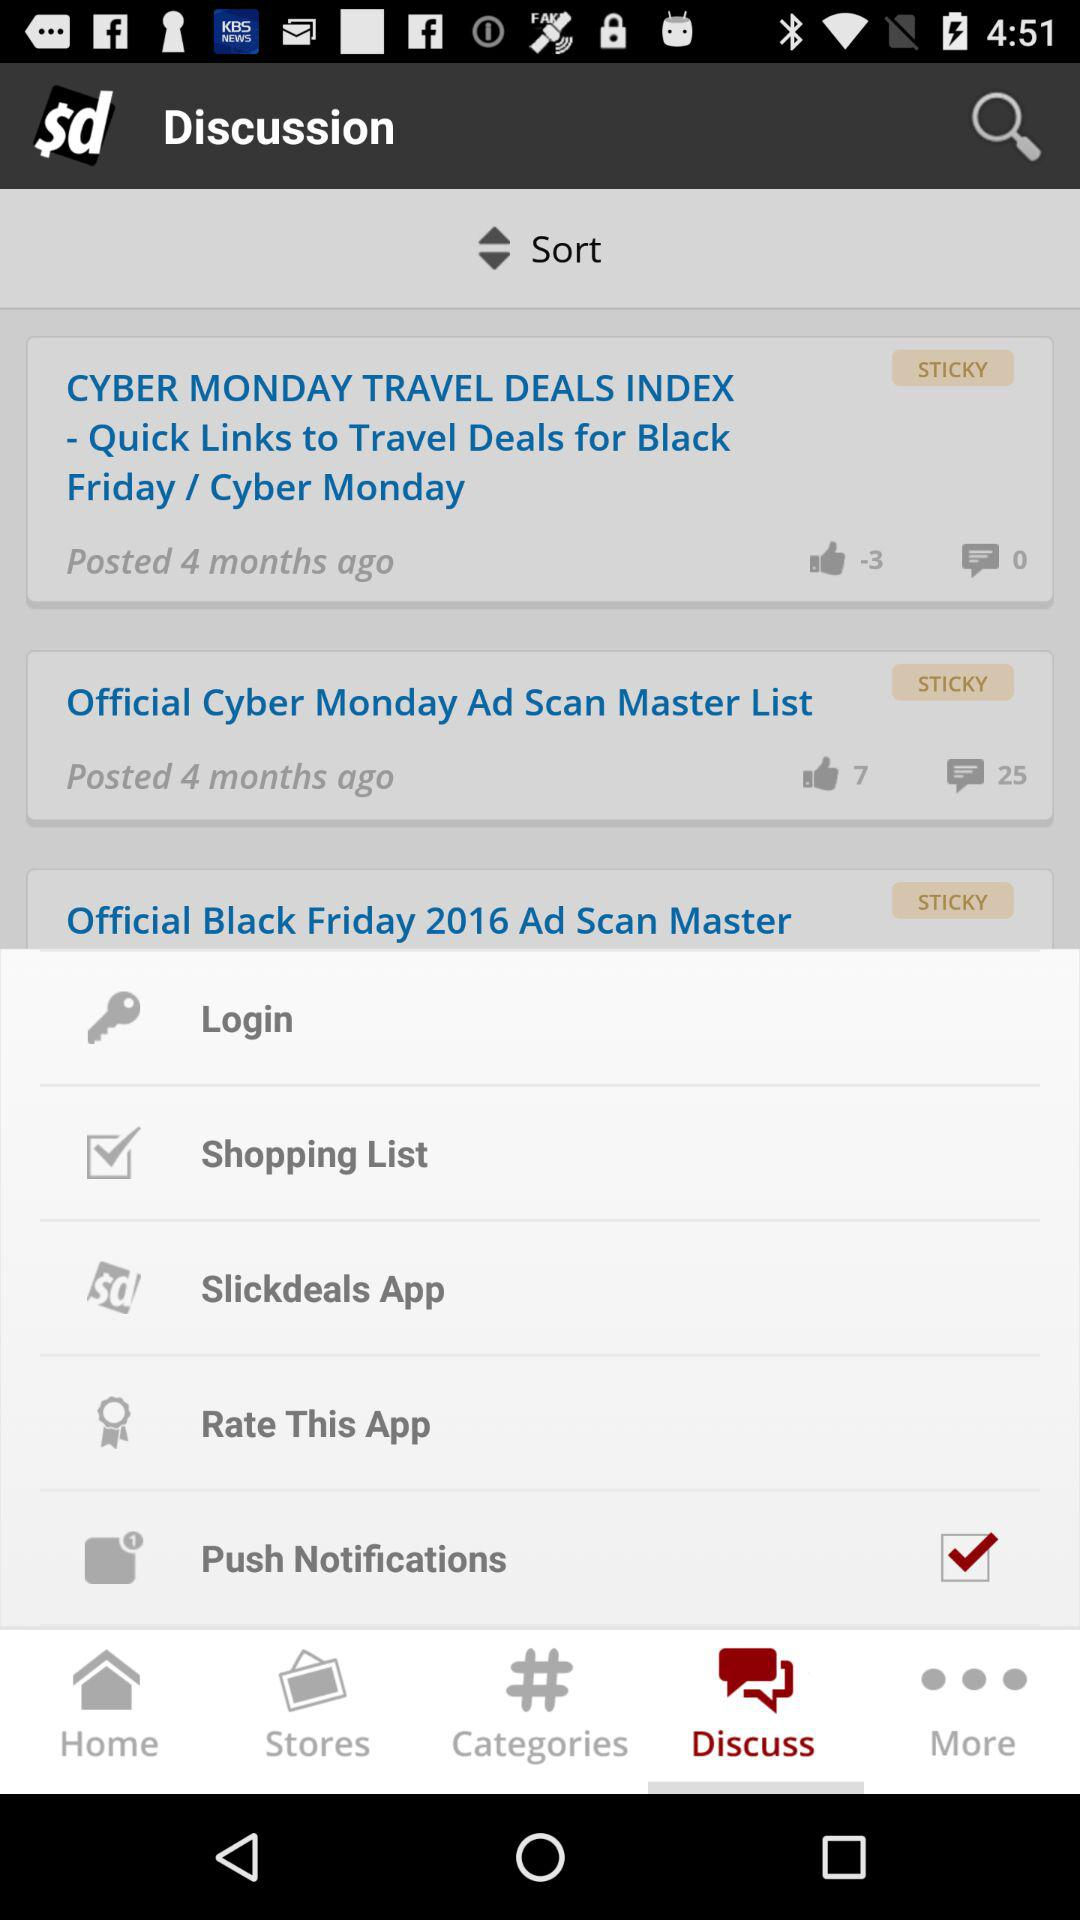What is the status of "Push Notifications"? The status is "on". 